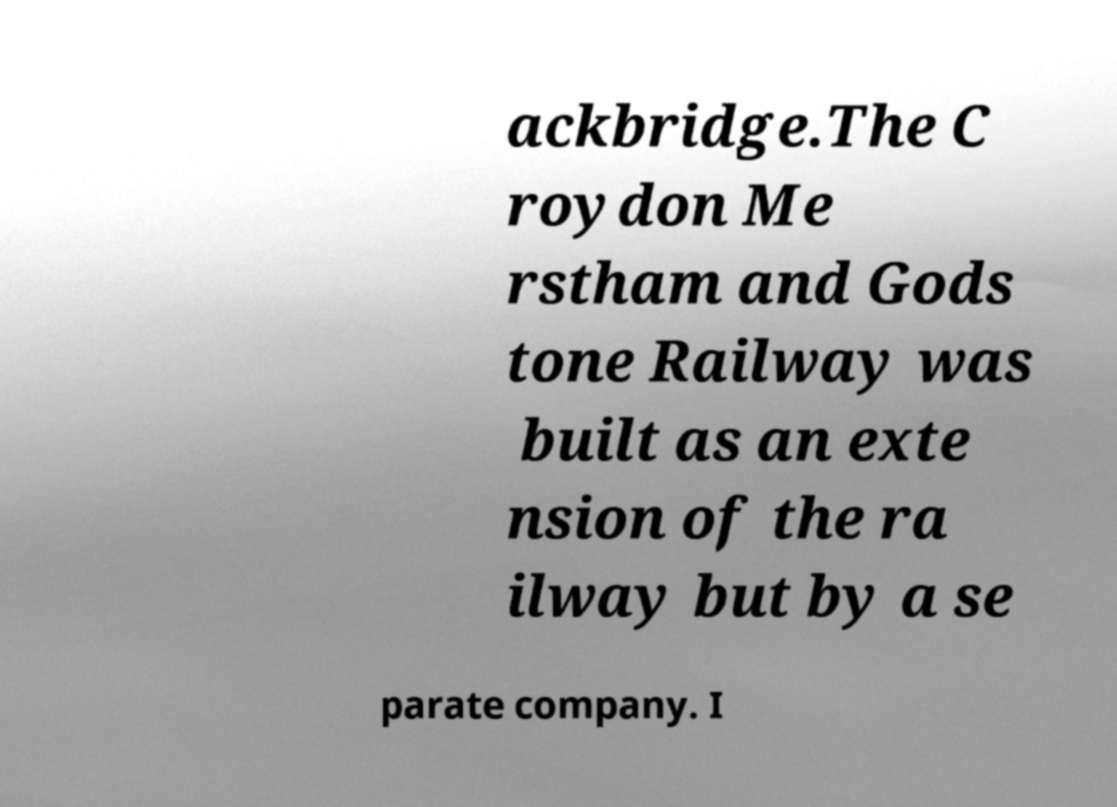Can you accurately transcribe the text from the provided image for me? ackbridge.The C roydon Me rstham and Gods tone Railway was built as an exte nsion of the ra ilway but by a se parate company. I 